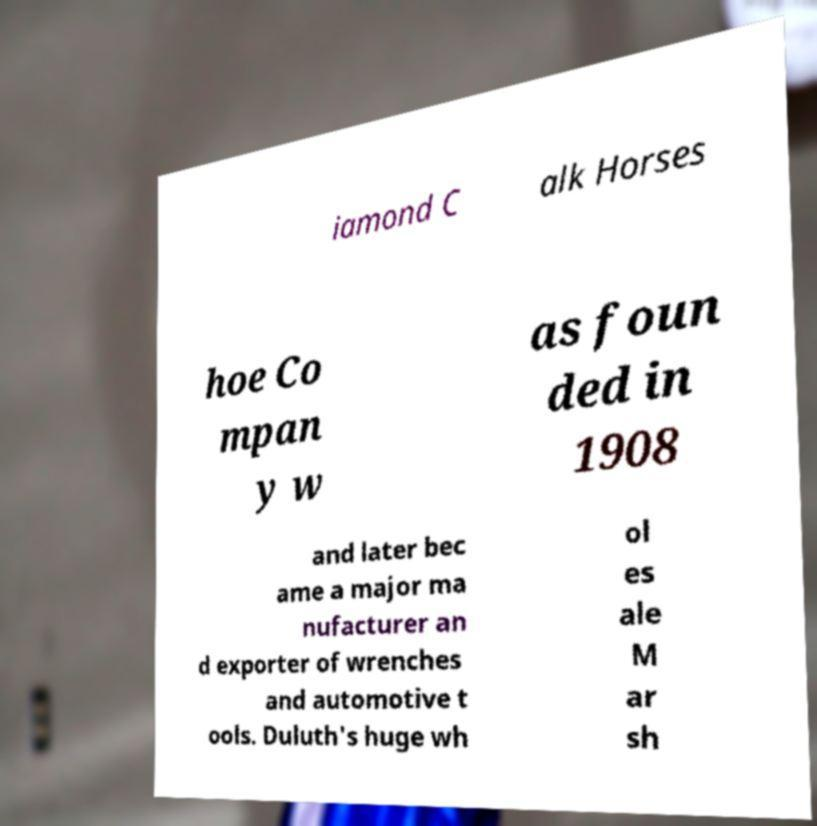Please read and relay the text visible in this image. What does it say? iamond C alk Horses hoe Co mpan y w as foun ded in 1908 and later bec ame a major ma nufacturer an d exporter of wrenches and automotive t ools. Duluth's huge wh ol es ale M ar sh 